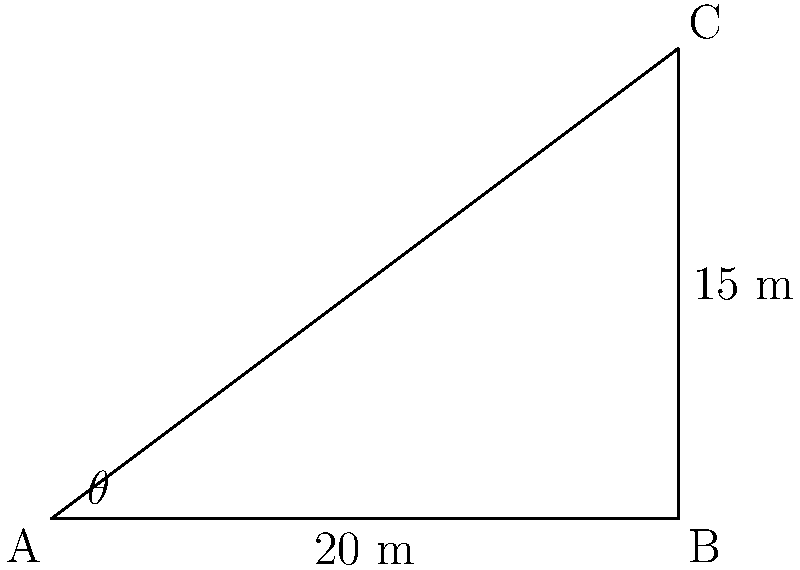As part of your field preparation, you need to determine the angle of a sloped section in your farm. You measure the horizontal distance from the bottom of the slope to be 20 meters, and the vertical height at that point to be 15 meters. Using this information and the right-angled triangle formed, calculate the angle of the slope (θ) to the nearest degree. To solve this problem, we'll use the trigonometric function tangent (tan). In a right-angled triangle, tan is the ratio of the opposite side to the adjacent side.

Step 1: Identify the sides of the right-angled triangle
- Opposite side (vertical height) = 15 m
- Adjacent side (horizontal distance) = 20 m
- Hypotenuse (slope length) is not needed for this calculation

Step 2: Set up the tangent equation
$\tan(\theta) = \frac{\text{opposite}}{\text{adjacent}} = \frac{15}{20}$

Step 3: Solve for θ using the inverse tangent (arctan or $\tan^{-1}$)
$\theta = \tan^{-1}(\frac{15}{20})$

Step 4: Calculate the result
$\theta = \tan^{-1}(0.75) \approx 36.87°$

Step 5: Round to the nearest degree
$\theta \approx 37°$
Answer: 37° 